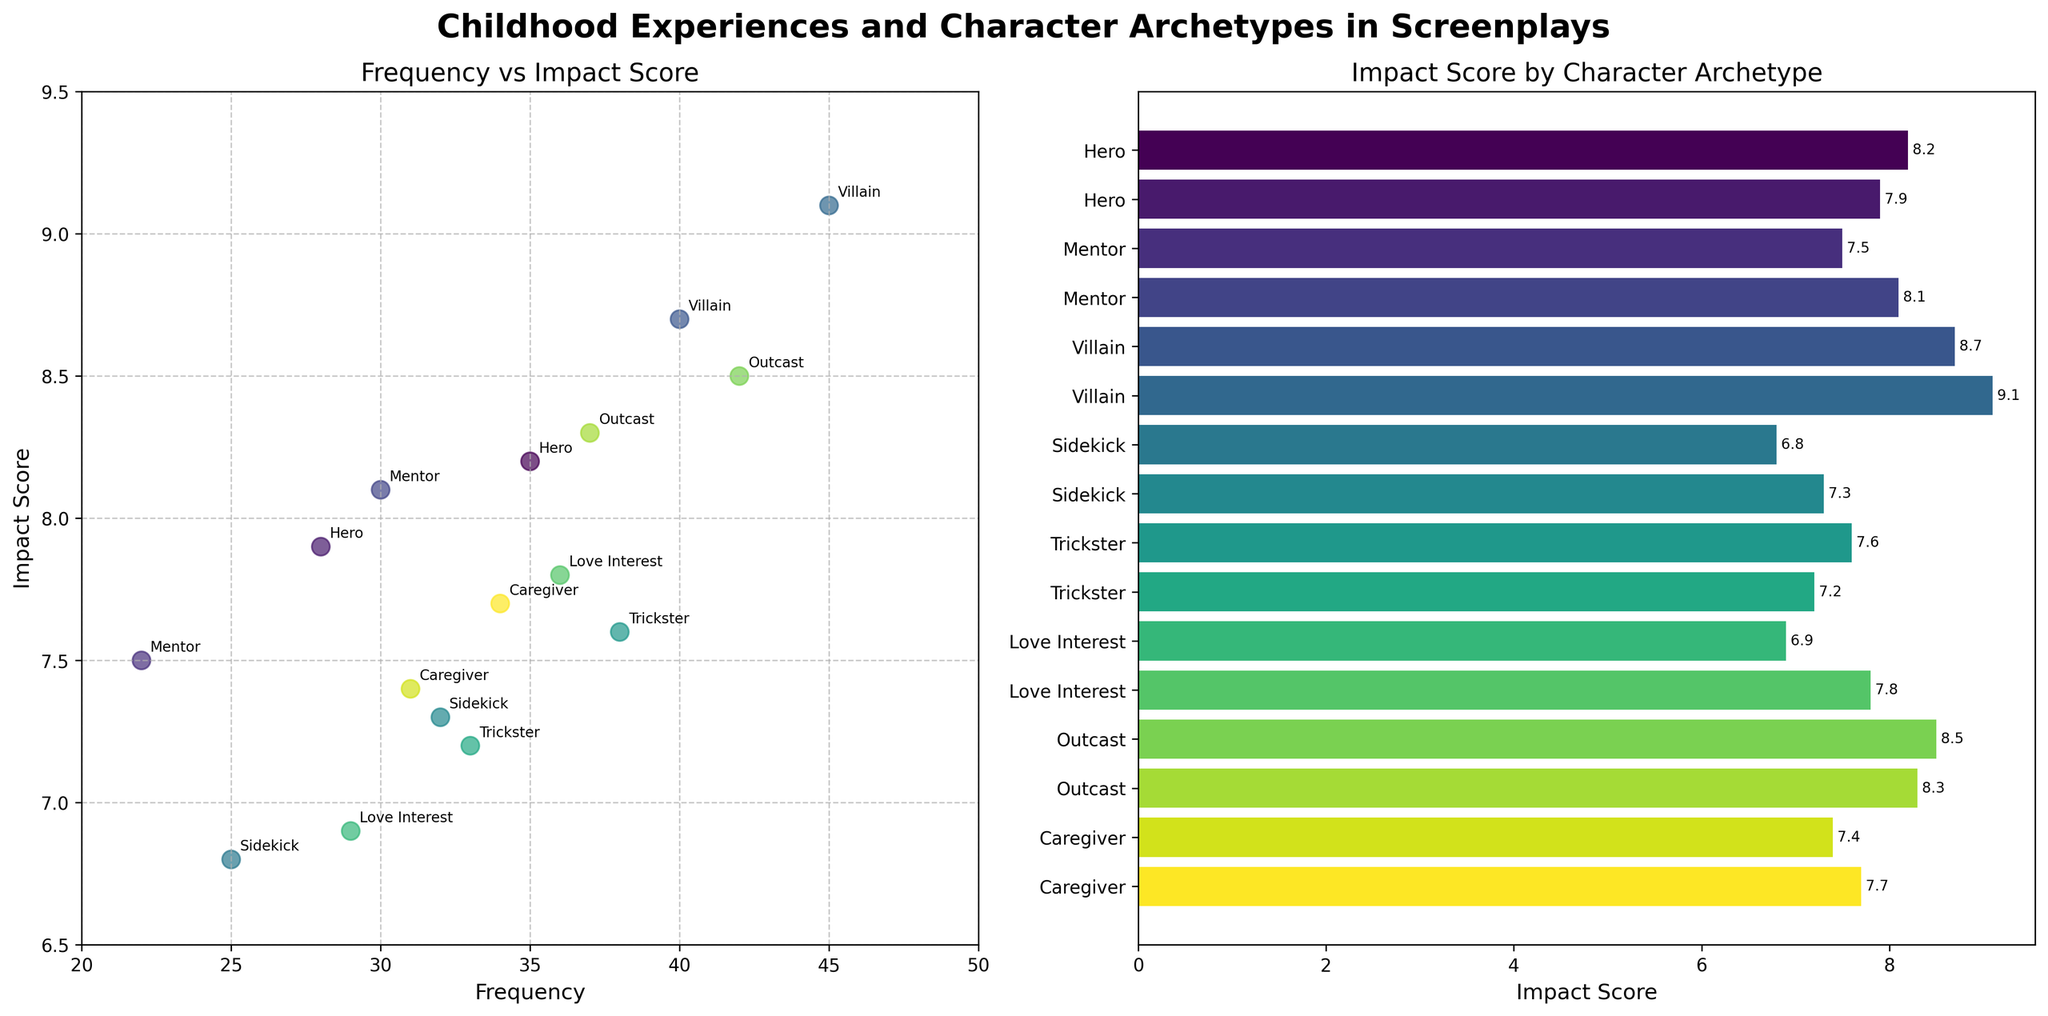What is the title of the figure? The title is typically found at the top of the figure and in this case, it should summarize the main topic or relationship shown in the plot.
Answer: Childhood Experiences and Character Archetypes in Screenplays How many character archetypes are represented in the horizontal bar chart? Count the number of y-ticks (labels) in the horizontal bar chart to determine the different character archetypes.
Answer: 8 Which childhood experience is associated with the highest impact score on the scatter plot? Identify the point with the highest y-value (Impact Score) on the scatter plot and check its associated label.
Answer: Villain with Childhood Trauma What is the impact score of the Hero archetype in the horizontal bar chart? Find the label 'Hero' on the left side of the horizontal bar chart and read the corresponding value at the end of the bar.
Answer: 8.2 Which character archetype has the closest frequency to 30 in the scatter plot? Look for the data point near the x-value of 30 and check its label to find the closest character archetype.
Answer: Mentor with Early Responsibility Which character archetype has the lowest impact score in the horizontal bar chart? Identify the bar with the smallest value on the x-axis and check its corresponding label.
Answer: Sidekick How does the impact score of a Mentor with Wise Grandparent compare to that of a Trickster with Divorced Parents? Locate the bars for each archetype and compare the lengths to determine which is longer.
Answer: Mentor with Wise Grandparent has a lower impact score than Trickster with Divorced Parents What's the average impact score of the Caregiver archetypes (Large Family and Single Parent Household) in the scatter plot? Add the impact scores of Caregiver archetypes (7.4 and 7.7) and then divide by 2 to get the average.
Answer: 7.55 Which character archetype is labeled at the position (45, 9.1) on the scatter plot? Locate the data point at coordinates (45, 9.1) on the scatter plot and read the associated label.
Answer: Villain with Childhood Trauma Does the 'Outcast' archetype appear on both the scatter plot and horizontal bar chart, and if so, with what impact score? Check both plots for the presence of 'Outcast' and note their impact scores from both visualizations.
Answer: Yes, 8.5 